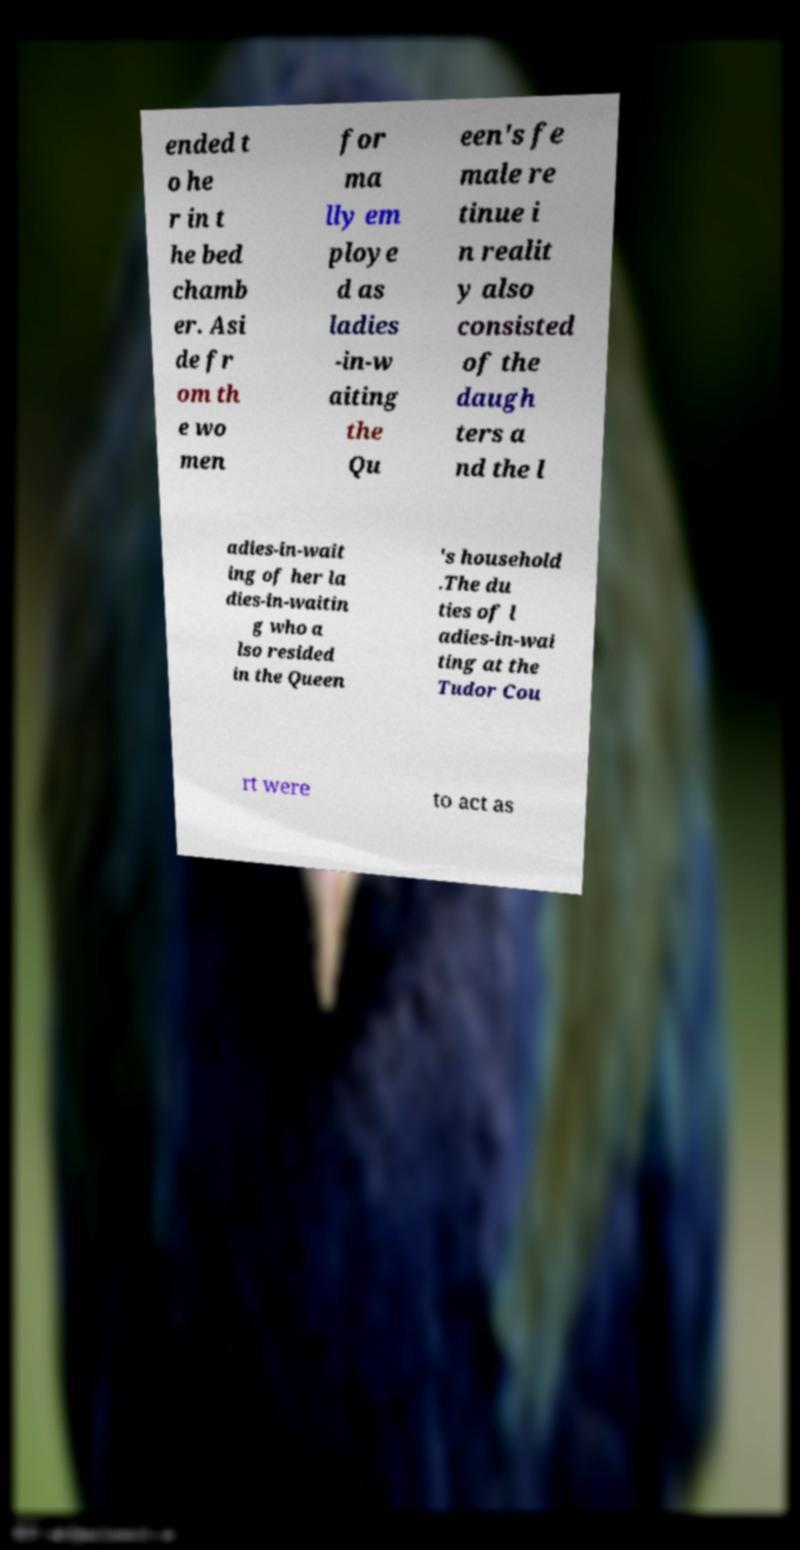I need the written content from this picture converted into text. Can you do that? ended t o he r in t he bed chamb er. Asi de fr om th e wo men for ma lly em ploye d as ladies -in-w aiting the Qu een's fe male re tinue i n realit y also consisted of the daugh ters a nd the l adies-in-wait ing of her la dies-in-waitin g who a lso resided in the Queen 's household .The du ties of l adies-in-wai ting at the Tudor Cou rt were to act as 